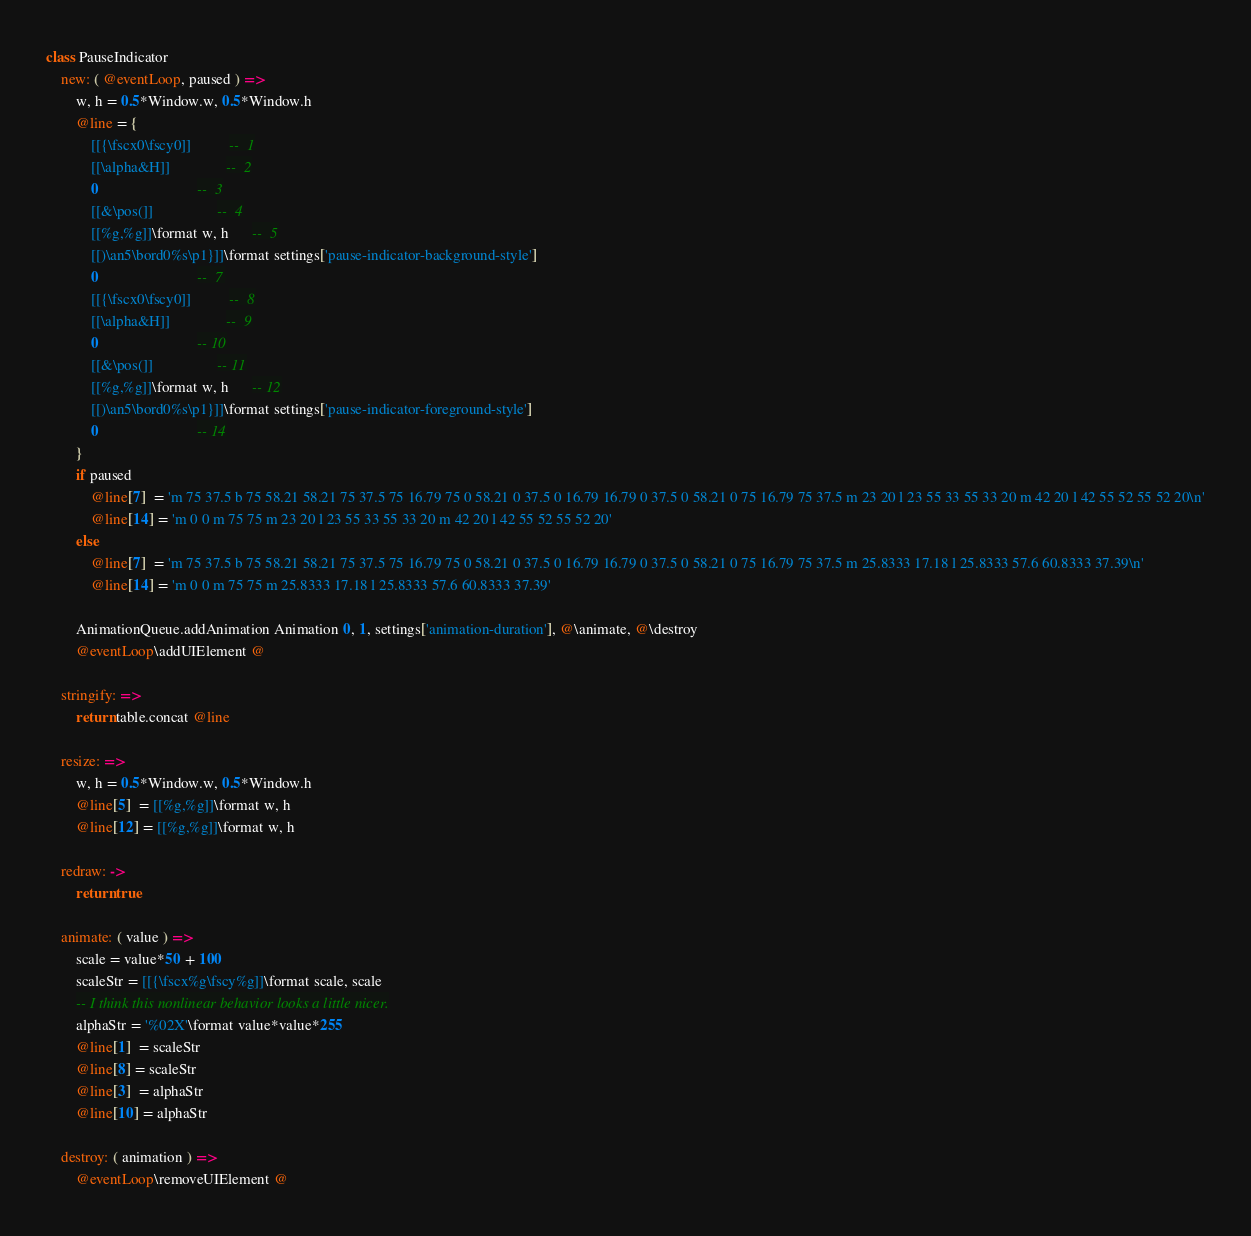Convert code to text. <code><loc_0><loc_0><loc_500><loc_500><_MoonScript_>class PauseIndicator
	new: ( @eventLoop, paused ) =>
		w, h = 0.5*Window.w, 0.5*Window.h
		@line = {
			[[{\fscx0\fscy0]]          --  1
			[[\alpha&H]]               --  2
			0                          --  3
			[[&\pos(]]                 --  4
			[[%g,%g]]\format w, h      --  5
			[[)\an5\bord0%s\p1}]]\format settings['pause-indicator-background-style']
			0                          --  7
			[[{\fscx0\fscy0]]          --  8
			[[\alpha&H]]               --  9
			0                          -- 10
			[[&\pos(]]                 -- 11
			[[%g,%g]]\format w, h      -- 12
			[[)\an5\bord0%s\p1}]]\format settings['pause-indicator-foreground-style']
			0                          -- 14
		}
		if paused
			@line[7]  = 'm 75 37.5 b 75 58.21 58.21 75 37.5 75 16.79 75 0 58.21 0 37.5 0 16.79 16.79 0 37.5 0 58.21 0 75 16.79 75 37.5 m 23 20 l 23 55 33 55 33 20 m 42 20 l 42 55 52 55 52 20\n'
			@line[14] = 'm 0 0 m 75 75 m 23 20 l 23 55 33 55 33 20 m 42 20 l 42 55 52 55 52 20'
		else
			@line[7]  = 'm 75 37.5 b 75 58.21 58.21 75 37.5 75 16.79 75 0 58.21 0 37.5 0 16.79 16.79 0 37.5 0 58.21 0 75 16.79 75 37.5 m 25.8333 17.18 l 25.8333 57.6 60.8333 37.39\n'
			@line[14] = 'm 0 0 m 75 75 m 25.8333 17.18 l 25.8333 57.6 60.8333 37.39'

		AnimationQueue.addAnimation Animation 0, 1, settings['animation-duration'], @\animate, @\destroy
		@eventLoop\addUIElement @

	stringify: =>
		return table.concat @line

	resize: =>
		w, h = 0.5*Window.w, 0.5*Window.h
		@line[5]  = [[%g,%g]]\format w, h
		@line[12] = [[%g,%g]]\format w, h

	redraw: ->
		return true

	animate: ( value ) =>
		scale = value*50 + 100
		scaleStr = [[{\fscx%g\fscy%g]]\format scale, scale
		-- I think this nonlinear behavior looks a little nicer.
		alphaStr = '%02X'\format value*value*255
		@line[1]  = scaleStr
		@line[8] = scaleStr
		@line[3]  = alphaStr
		@line[10] = alphaStr

	destroy: ( animation ) =>
		@eventLoop\removeUIElement @
</code> 